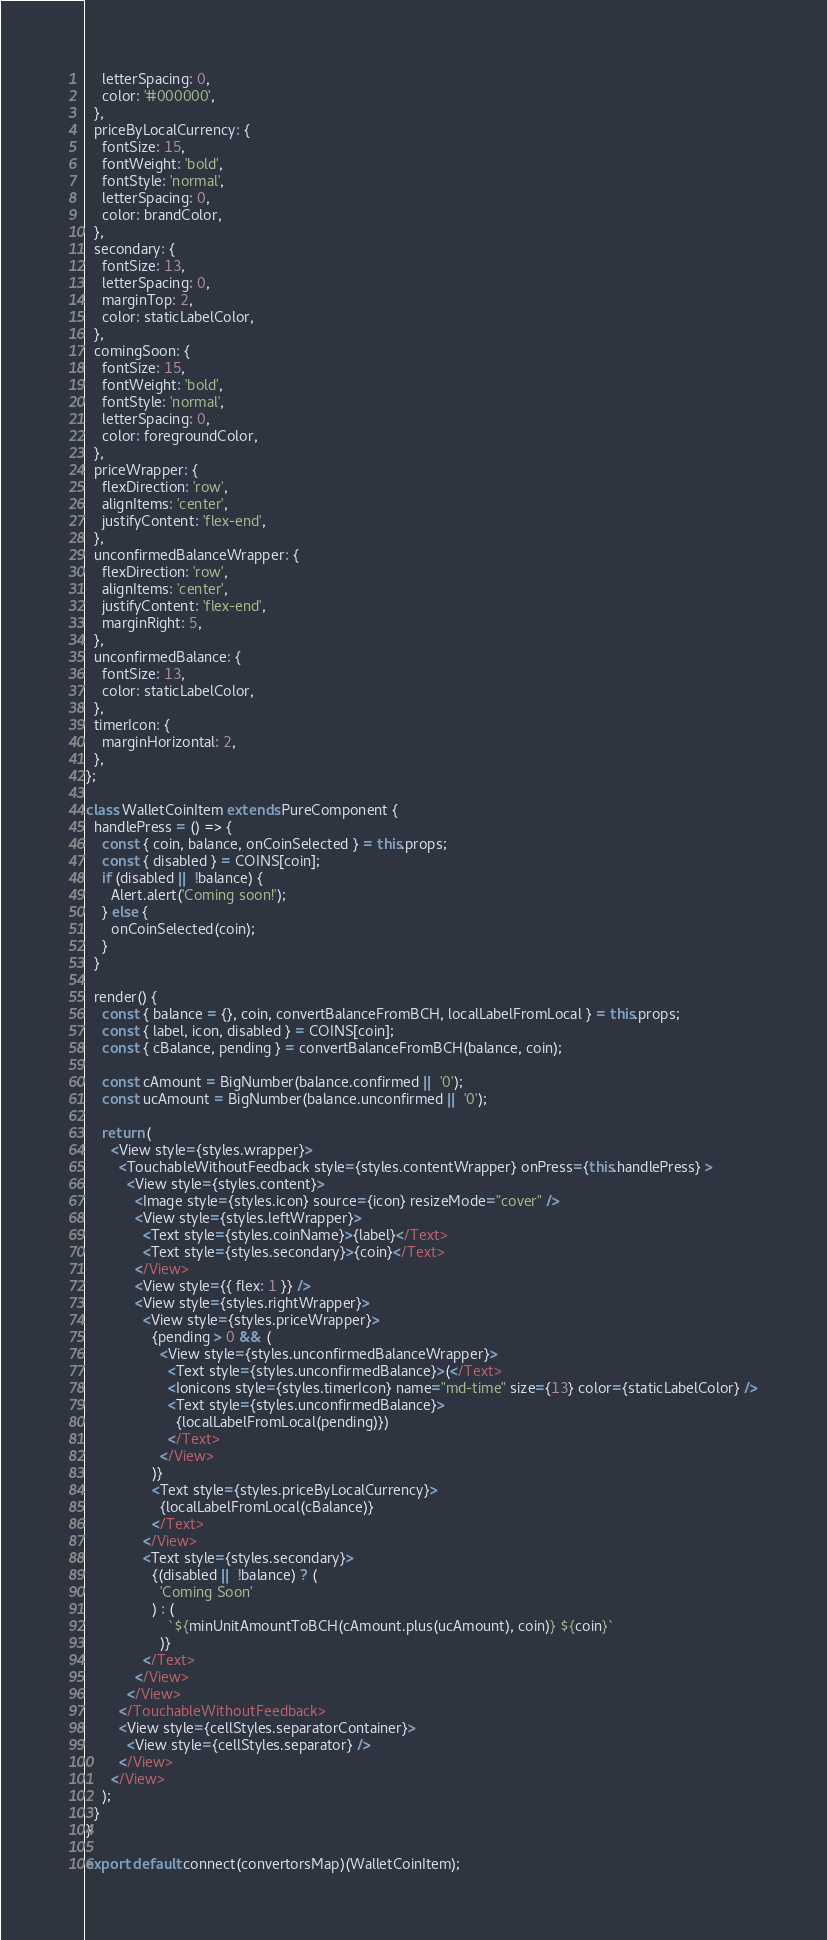Convert code to text. <code><loc_0><loc_0><loc_500><loc_500><_JavaScript_>    letterSpacing: 0,
    color: '#000000',
  },
  priceByLocalCurrency: {
    fontSize: 15,
    fontWeight: 'bold',
    fontStyle: 'normal',
    letterSpacing: 0,
    color: brandColor,
  },
  secondary: {
    fontSize: 13,
    letterSpacing: 0,
    marginTop: 2,
    color: staticLabelColor,
  },
  comingSoon: {
    fontSize: 15,
    fontWeight: 'bold',
    fontStyle: 'normal',
    letterSpacing: 0,
    color: foregroundColor,
  },
  priceWrapper: {
    flexDirection: 'row',
    alignItems: 'center',
    justifyContent: 'flex-end',
  },
  unconfirmedBalanceWrapper: {
    flexDirection: 'row',
    alignItems: 'center',
    justifyContent: 'flex-end',
    marginRight: 5,
  },
  unconfirmedBalance: {
    fontSize: 13,
    color: staticLabelColor,
  },
  timerIcon: {
    marginHorizontal: 2,
  },
};

class WalletCoinItem extends PureComponent {
  handlePress = () => {
    const { coin, balance, onCoinSelected } = this.props;
    const { disabled } = COINS[coin];
    if (disabled || !balance) {
      Alert.alert('Coming soon!');
    } else {
      onCoinSelected(coin);
    }
  }

  render() {
    const { balance = {}, coin, convertBalanceFromBCH, localLabelFromLocal } = this.props;
    const { label, icon, disabled } = COINS[coin];
    const { cBalance, pending } = convertBalanceFromBCH(balance, coin);

    const cAmount = BigNumber(balance.confirmed || '0');
    const ucAmount = BigNumber(balance.unconfirmed || '0');

    return (
      <View style={styles.wrapper}>
        <TouchableWithoutFeedback style={styles.contentWrapper} onPress={this.handlePress} >
          <View style={styles.content}>
            <Image style={styles.icon} source={icon} resizeMode="cover" />
            <View style={styles.leftWrapper}>
              <Text style={styles.coinName}>{label}</Text>
              <Text style={styles.secondary}>{coin}</Text>
            </View>
            <View style={{ flex: 1 }} />
            <View style={styles.rightWrapper}>
              <View style={styles.priceWrapper}>
                {pending > 0 && (
                  <View style={styles.unconfirmedBalanceWrapper}>
                    <Text style={styles.unconfirmedBalance}>(</Text>
                    <Ionicons style={styles.timerIcon} name="md-time" size={13} color={staticLabelColor} />
                    <Text style={styles.unconfirmedBalance}>
                      {localLabelFromLocal(pending)})
                    </Text>
                  </View>
                )}
                <Text style={styles.priceByLocalCurrency}>
                  {localLabelFromLocal(cBalance)}
                </Text>
              </View>
              <Text style={styles.secondary}>
                {(disabled || !balance) ? (
                  'Coming Soon'
                ) : (
                    `${minUnitAmountToBCH(cAmount.plus(ucAmount), coin)} ${coin}`
                  )}
              </Text>
            </View>
          </View>
        </TouchableWithoutFeedback>
        <View style={cellStyles.separatorContainer}>
          <View style={cellStyles.separator} />
        </View>
      </View>
    );
  }
}

export default connect(convertorsMap)(WalletCoinItem);
</code> 